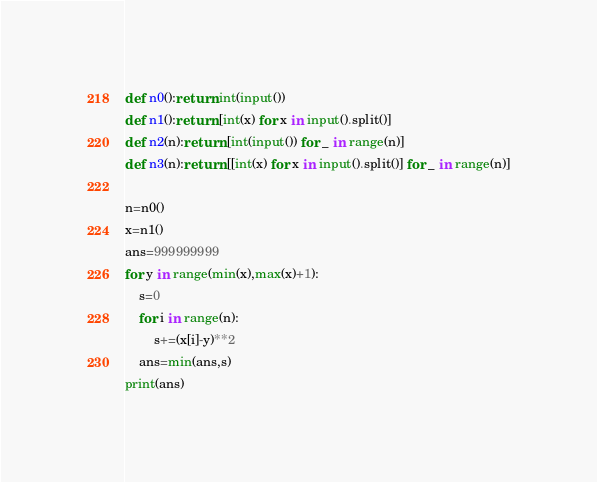Convert code to text. <code><loc_0><loc_0><loc_500><loc_500><_Python_>def n0():return int(input())
def n1():return [int(x) for x in input().split()]
def n2(n):return [int(input()) for _ in range(n)]
def n3(n):return [[int(x) for x in input().split()] for _ in range(n)]

n=n0()
x=n1()
ans=999999999
for y in range(min(x),max(x)+1):
    s=0
    for i in range(n):
        s+=(x[i]-y)**2
    ans=min(ans,s)
print(ans)</code> 